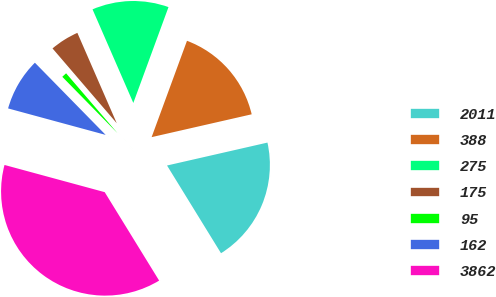<chart> <loc_0><loc_0><loc_500><loc_500><pie_chart><fcel>2011<fcel>388<fcel>275<fcel>175<fcel>95<fcel>162<fcel>3862<nl><fcel>19.79%<fcel>15.83%<fcel>12.14%<fcel>4.75%<fcel>1.05%<fcel>8.44%<fcel>38.0%<nl></chart> 